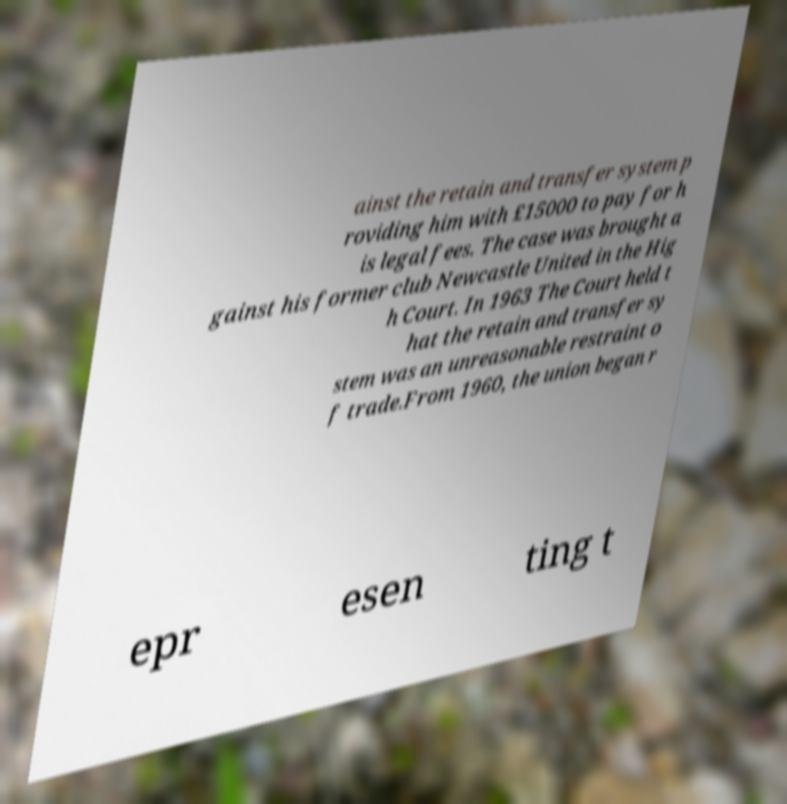Can you read and provide the text displayed in the image?This photo seems to have some interesting text. Can you extract and type it out for me? ainst the retain and transfer system p roviding him with £15000 to pay for h is legal fees. The case was brought a gainst his former club Newcastle United in the Hig h Court. In 1963 The Court held t hat the retain and transfer sy stem was an unreasonable restraint o f trade.From 1960, the union began r epr esen ting t 